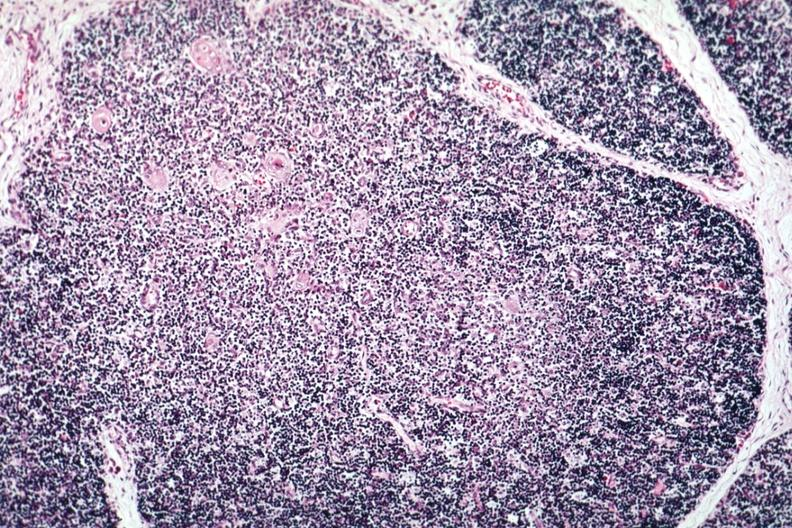s normal immature infant present?
Answer the question using a single word or phrase. Yes 